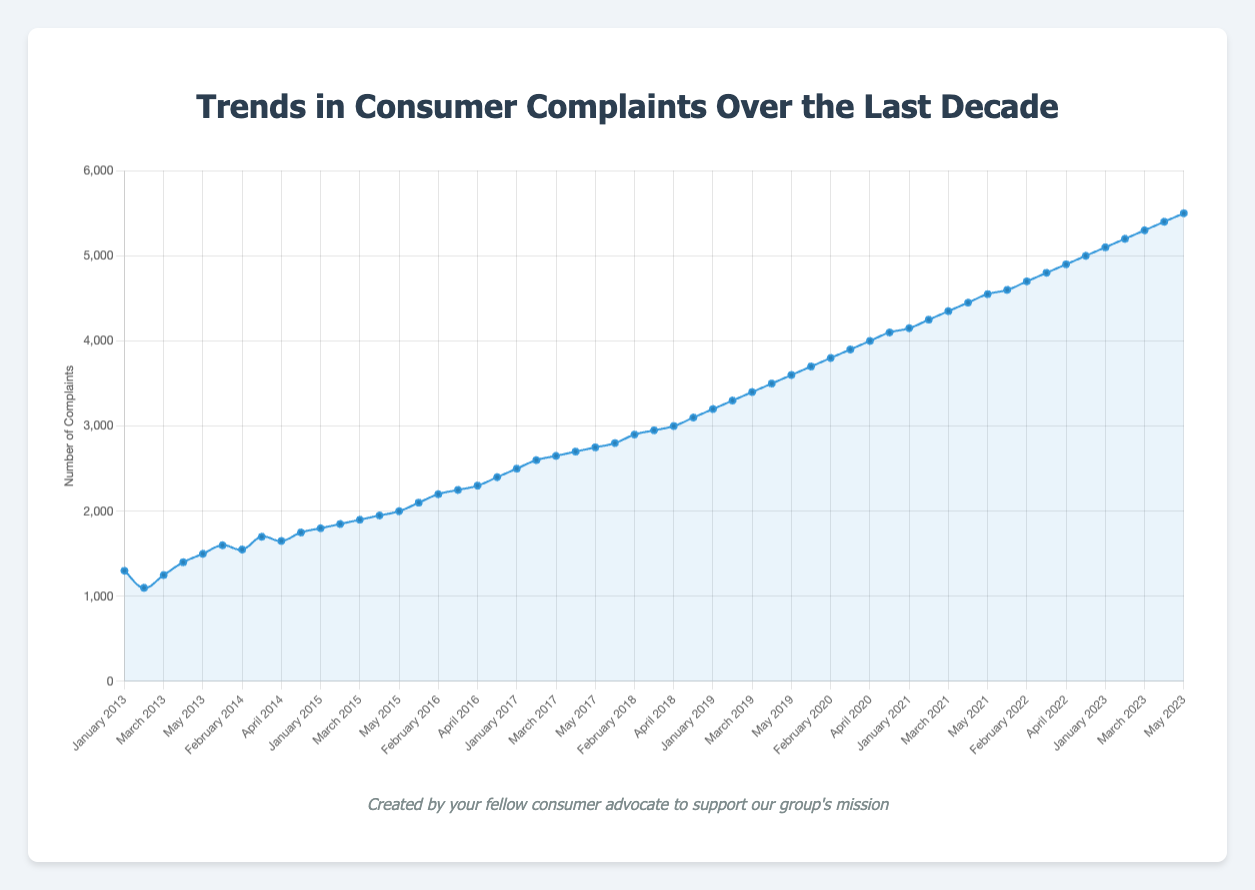What's the trend in the number of consumer complaints from 2013 to 2023? The figure shows the overall direction of the line from 2013 to 2023. The line consistently moves upward, indicating a gradual increase in the number of complaints over the decade.
Answer: Gradually increasing Which month and year had the highest number of complaints? By looking at the peak point of the line in the graph, we can see that May 2023 had the highest number of complaints.
Answer: May 2023 Compare the number of complaints in January 2016 and January 2022. Which month had more complaints? Locate January 2016 and January 2022 on the timeline and compare their vertical positions. January 2022 is higher, indicating more complaints.
Answer: January 2022 What is the difference in the number of complaints between May 2013 and May 2023? Find the data points for May 2013 (1500 complaints) and May 2023 (5500 complaints). Subtract the number of complaints in May 2013 from May 2023. (5500 - 1500 = 4000)
Answer: 4000 What is the average number of complaints for the months in 2020? Add the complaints for all months in 2020: 3700 + 3800 + 3900 + 4000 + 4100 = 19500. Then divide by the number of months (5). 19500 / 5 = 3900
Answer: 3900 Which year saw the sharpest increase in complaints from January to May? Compare the increase from January to May for each year, calculating the difference. The sharpest increase is seen in 2022: January (4600) to May (5000), resulting in an increase of 5000 - 4600 = 400.
Answer: 2022 How does the number of complaints in February 2021 compare to February 2014? Look at complaints for February 2021 (4250) and February 2014 (1550) on the chart. February 2021 has a greater number of complaints.
Answer: February 2021 What is the total number of complaints for the first three months of 2015? Sum the number of complaints for January, February, and March 2015: 1800 + 1850 + 1900 = 5550
Answer: 5550 If we observe the trend from January to May each year, which year experienced a decline in complaints from the previous month? By visually following each year's line from January to May, check for any drops. There are no declines; complaints consistently increase month-over-month each year.
Answer: No declines What is the difference in the number of complaints between the peak month in 2018 and the peak month in 2023? Identify the peak months: May 2018 (3100) and May 2023 (5500). Subtract the 2018 value from the 2023 value (5500 - 3100 = 2400).
Answer: 2400 